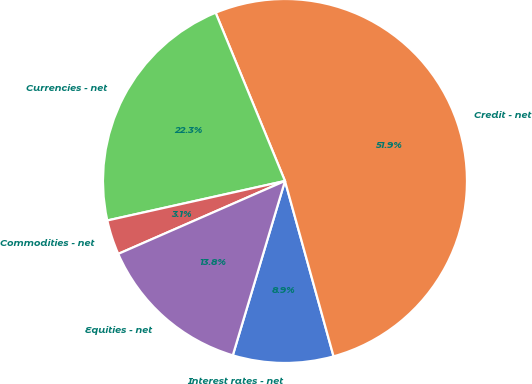Convert chart to OTSL. <chart><loc_0><loc_0><loc_500><loc_500><pie_chart><fcel>Interest rates - net<fcel>Credit - net<fcel>Currencies - net<fcel>Commodities - net<fcel>Equities - net<nl><fcel>8.93%<fcel>51.92%<fcel>22.26%<fcel>3.08%<fcel>13.81%<nl></chart> 